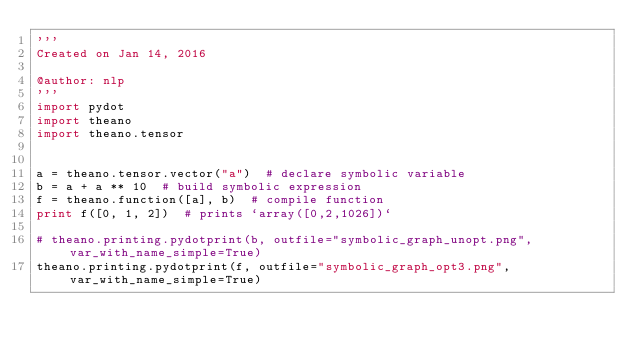Convert code to text. <code><loc_0><loc_0><loc_500><loc_500><_Python_>'''
Created on Jan 14, 2016

@author: nlp
'''
import pydot
import theano
import theano.tensor


a = theano.tensor.vector("a")  # declare symbolic variable
b = a + a ** 10  # build symbolic expression
f = theano.function([a], b)  # compile function
print f([0, 1, 2])  # prints `array([0,2,1026])`

# theano.printing.pydotprint(b, outfile="symbolic_graph_unopt.png", var_with_name_simple=True)  
theano.printing.pydotprint(f, outfile="symbolic_graph_opt3.png", var_with_name_simple=True)  
</code> 